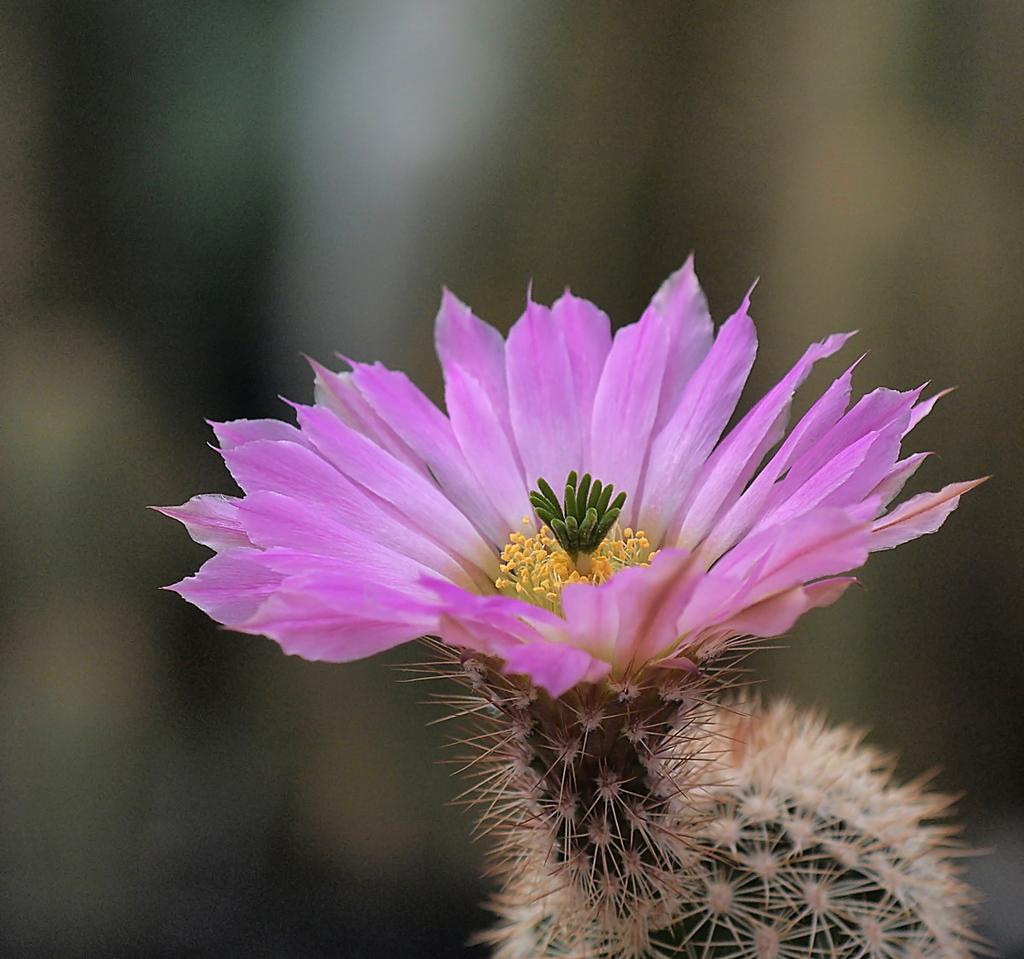In one or two sentences, can you explain what this image depicts? In this image there is a flower, there is a plant towards the bottom of the image, the background of the image is blurred. 